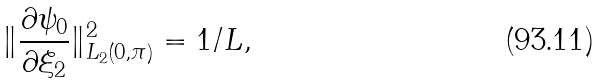Convert formula to latex. <formula><loc_0><loc_0><loc_500><loc_500>\| \frac { \partial \psi _ { 0 } } { \partial \xi _ { 2 } } \| ^ { 2 } _ { L _ { 2 } ( 0 , \pi ) } = 1 / L ,</formula> 